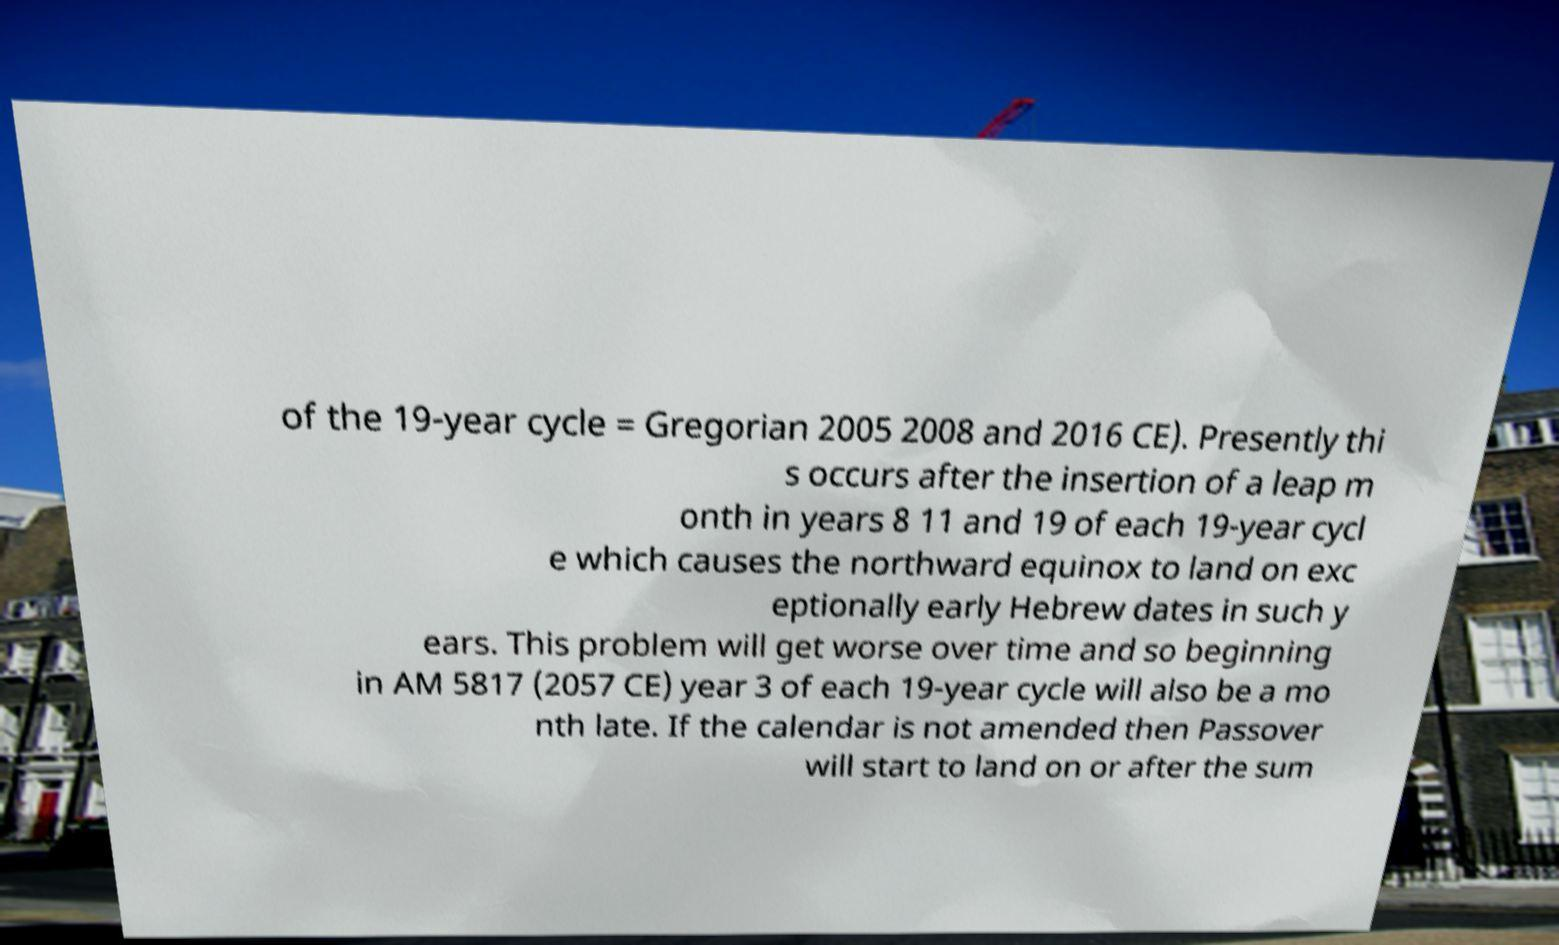What messages or text are displayed in this image? I need them in a readable, typed format. of the 19-year cycle = Gregorian 2005 2008 and 2016 CE). Presently thi s occurs after the insertion of a leap m onth in years 8 11 and 19 of each 19-year cycl e which causes the northward equinox to land on exc eptionally early Hebrew dates in such y ears. This problem will get worse over time and so beginning in AM 5817 (2057 CE) year 3 of each 19-year cycle will also be a mo nth late. If the calendar is not amended then Passover will start to land on or after the sum 